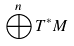Convert formula to latex. <formula><loc_0><loc_0><loc_500><loc_500>\bigoplus ^ { n } T ^ { * } M</formula> 